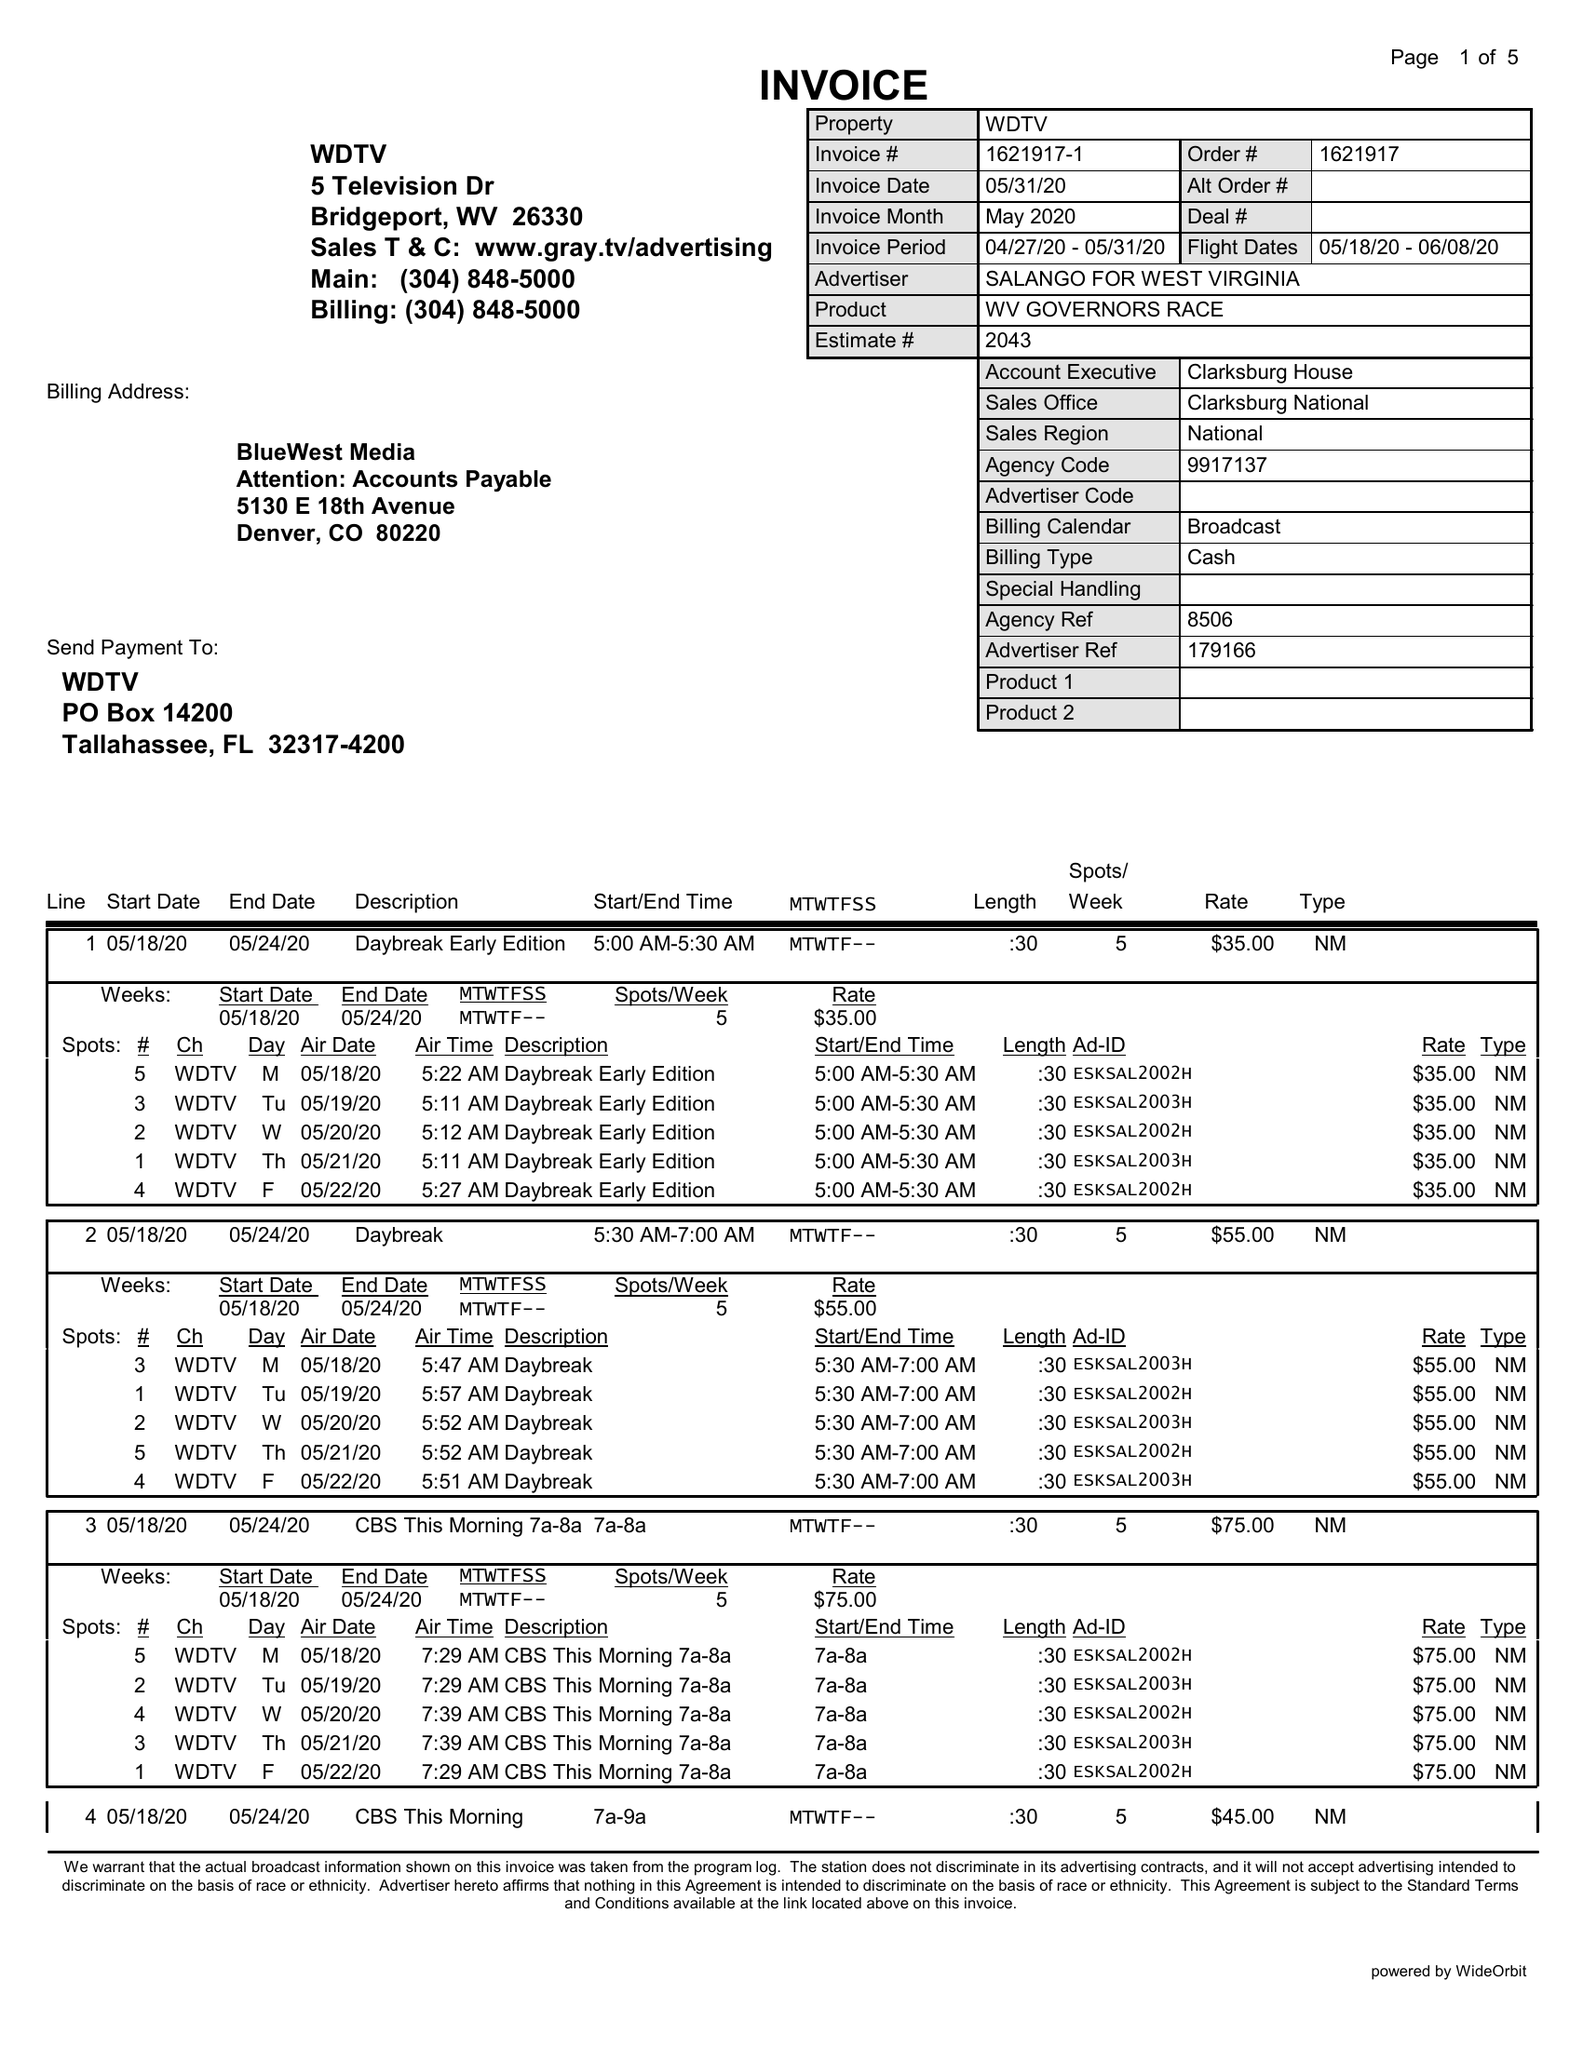What is the value for the contract_num?
Answer the question using a single word or phrase. 1621917 